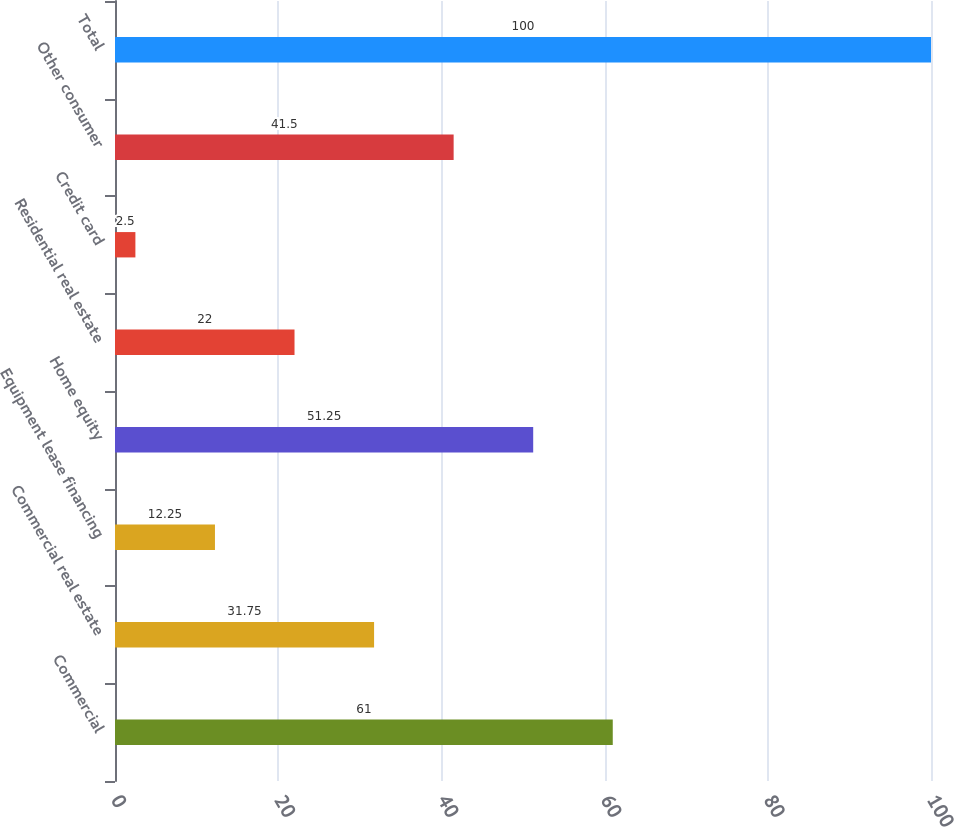Convert chart to OTSL. <chart><loc_0><loc_0><loc_500><loc_500><bar_chart><fcel>Commercial<fcel>Commercial real estate<fcel>Equipment lease financing<fcel>Home equity<fcel>Residential real estate<fcel>Credit card<fcel>Other consumer<fcel>Total<nl><fcel>61<fcel>31.75<fcel>12.25<fcel>51.25<fcel>22<fcel>2.5<fcel>41.5<fcel>100<nl></chart> 